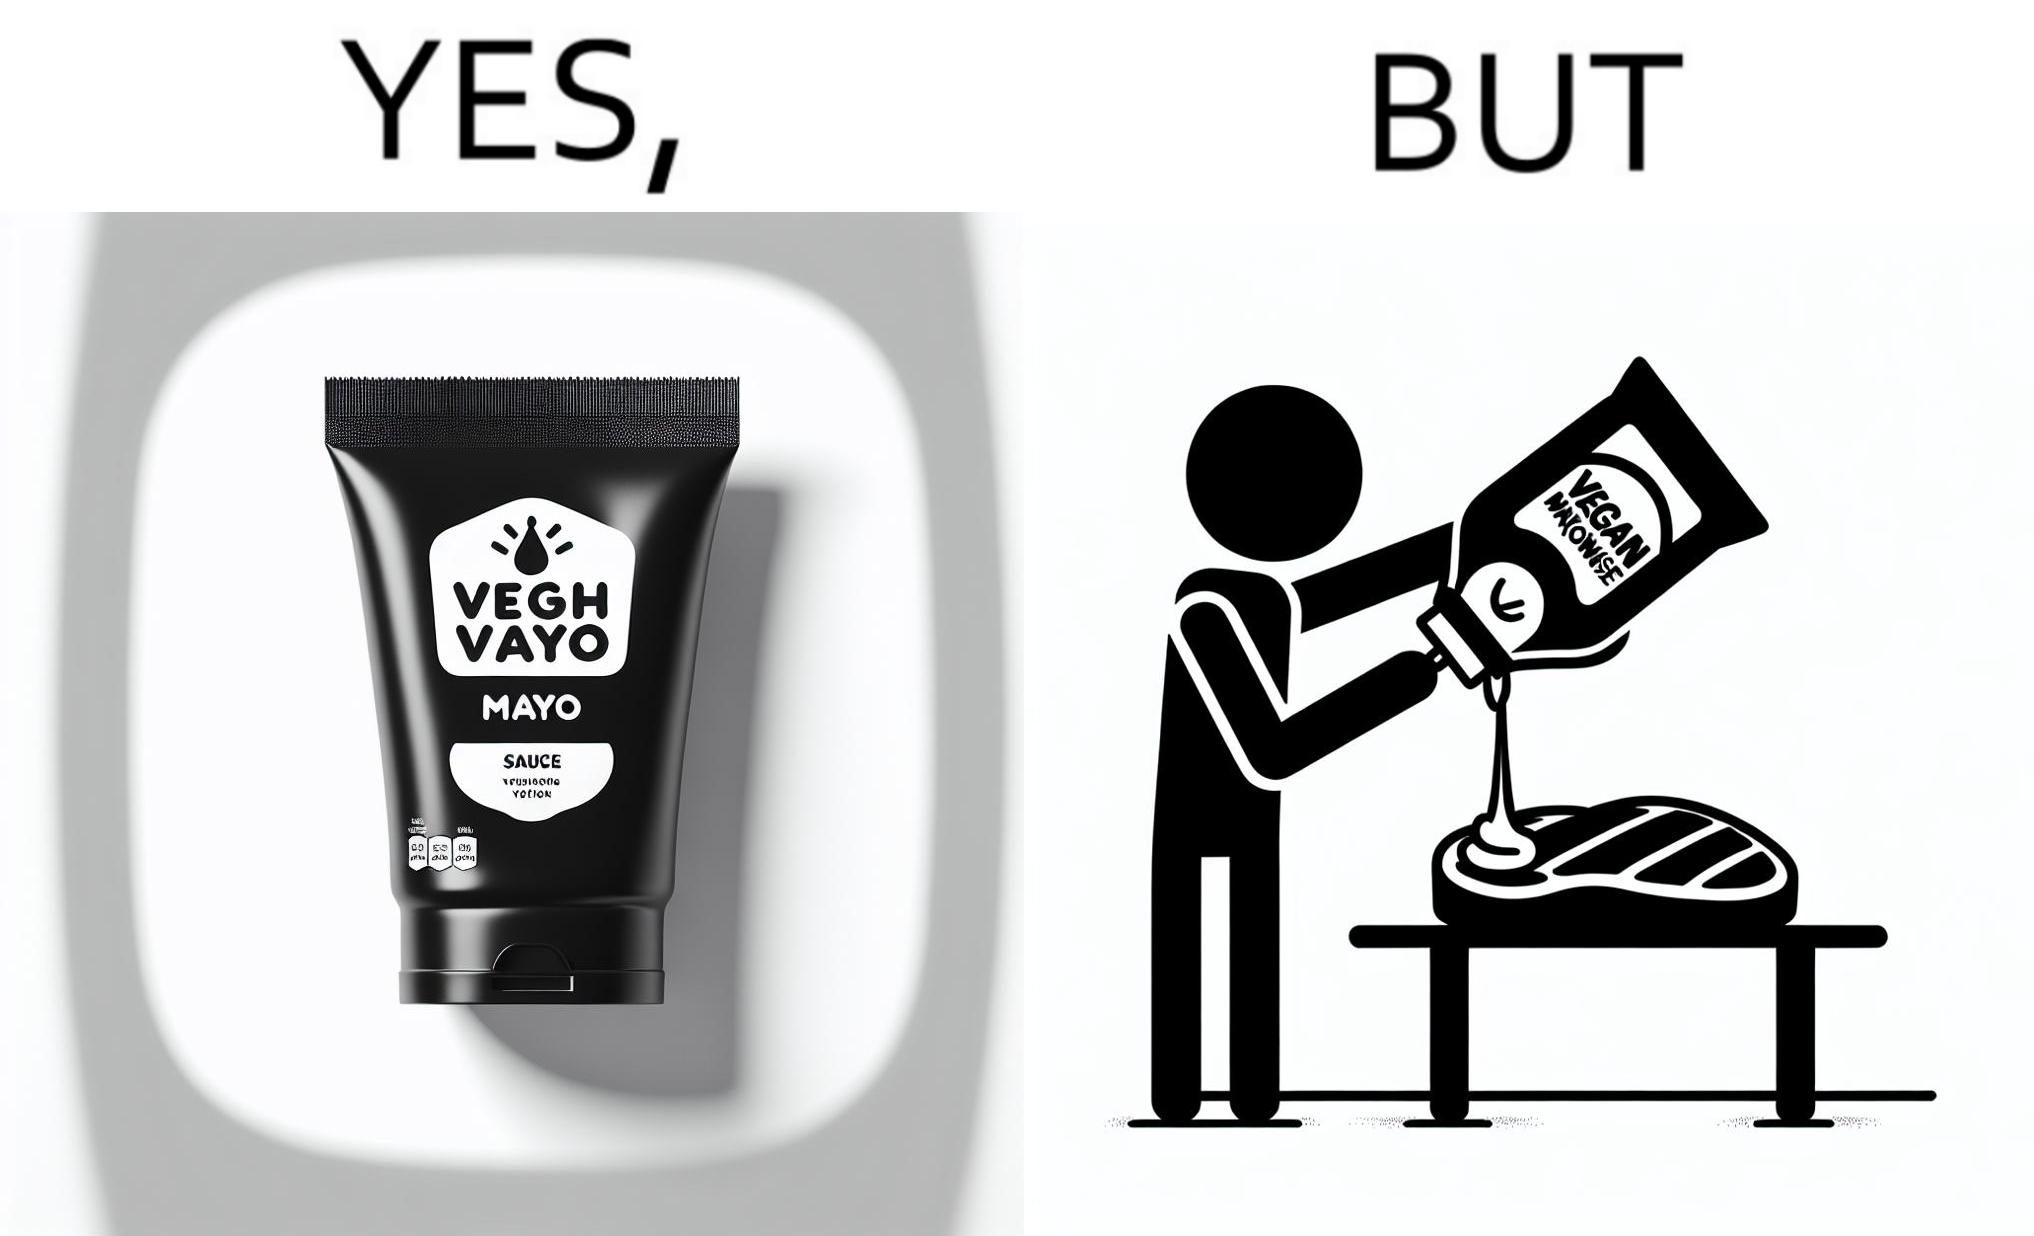What is shown in this image? The image is ironical, as vegan mayo sauce is being poured on rib steak, which is non-vegetarian. The person might as well just use normal mayo sauce instead. 